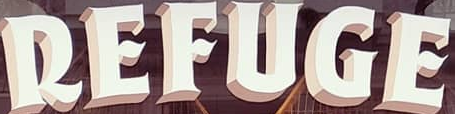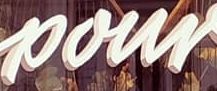What text is displayed in these images sequentially, separated by a semicolon? REFUGE; pour 